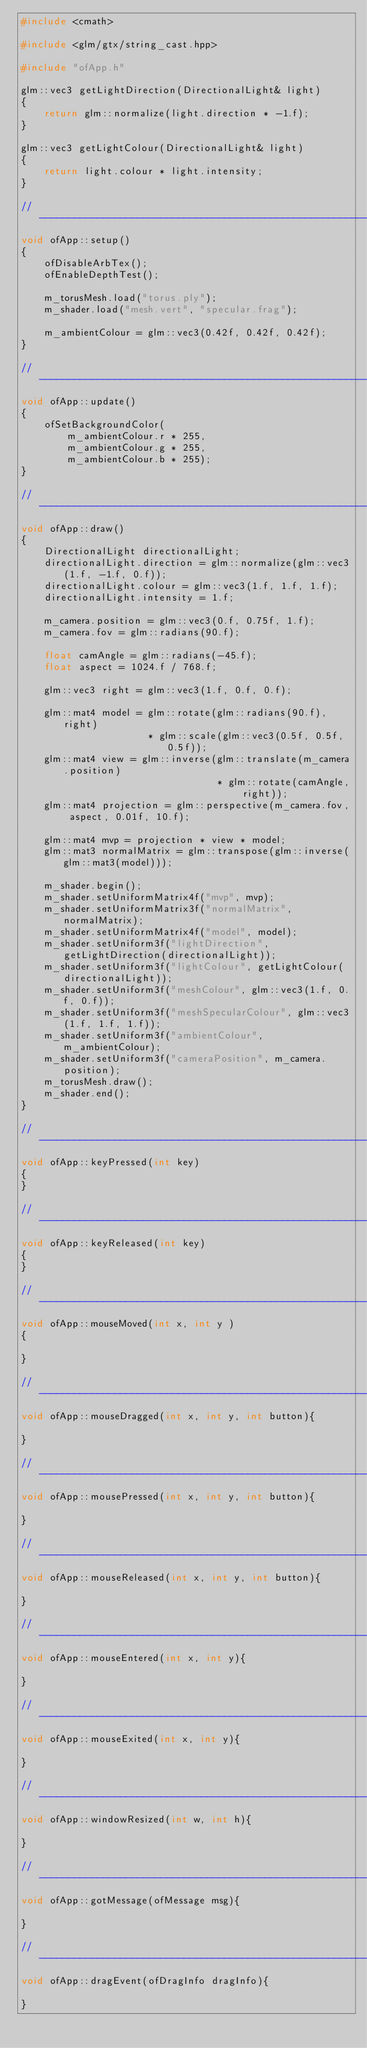Convert code to text. <code><loc_0><loc_0><loc_500><loc_500><_C++_>#include <cmath>

#include <glm/gtx/string_cast.hpp>

#include "ofApp.h"

glm::vec3 getLightDirection(DirectionalLight& light)
{
    return glm::normalize(light.direction * -1.f);
}

glm::vec3 getLightColour(DirectionalLight& light)
{
    return light.colour * light.intensity;
}

//--------------------------------------------------------------
void ofApp::setup()
{
    ofDisableArbTex();
    ofEnableDepthTest();

    m_torusMesh.load("torus.ply");
    m_shader.load("mesh.vert", "specular.frag");

    m_ambientColour = glm::vec3(0.42f, 0.42f, 0.42f);
}

//--------------------------------------------------------------
void ofApp::update()
{
    ofSetBackgroundColor(
        m_ambientColour.r * 255,
        m_ambientColour.g * 255,
        m_ambientColour.b * 255);
}

//--------------------------------------------------------------
void ofApp::draw()
{
    DirectionalLight directionalLight;
    directionalLight.direction = glm::normalize(glm::vec3(1.f, -1.f, 0.f));
    directionalLight.colour = glm::vec3(1.f, 1.f, 1.f);
    directionalLight.intensity = 1.f;

    m_camera.position = glm::vec3(0.f, 0.75f, 1.f);
    m_camera.fov = glm::radians(90.f);

    float camAngle = glm::radians(-45.f);
    float aspect = 1024.f / 768.f;

    glm::vec3 right = glm::vec3(1.f, 0.f, 0.f);

    glm::mat4 model = glm::rotate(glm::radians(90.f), right)
                      * glm::scale(glm::vec3(0.5f, 0.5f, 0.5f));
    glm::mat4 view = glm::inverse(glm::translate(m_camera.position)
                                  * glm::rotate(camAngle, right));
    glm::mat4 projection = glm::perspective(m_camera.fov, aspect, 0.01f, 10.f);

    glm::mat4 mvp = projection * view * model;
    glm::mat3 normalMatrix = glm::transpose(glm::inverse(glm::mat3(model)));

    m_shader.begin();
    m_shader.setUniformMatrix4f("mvp", mvp);
    m_shader.setUniformMatrix3f("normalMatrix", normalMatrix);
    m_shader.setUniformMatrix4f("model", model);
    m_shader.setUniform3f("lightDirection", getLightDirection(directionalLight));
    m_shader.setUniform3f("lightColour", getLightColour(directionalLight));
    m_shader.setUniform3f("meshColour", glm::vec3(1.f, 0.f, 0.f));
    m_shader.setUniform3f("meshSpecularColour", glm::vec3(1.f, 1.f, 1.f));
    m_shader.setUniform3f("ambientColour", m_ambientColour);
    m_shader.setUniform3f("cameraPosition", m_camera.position);
    m_torusMesh.draw();
    m_shader.end();
}

//--------------------------------------------------------------
void ofApp::keyPressed(int key)
{
}

//--------------------------------------------------------------
void ofApp::keyReleased(int key)
{
}

//--------------------------------------------------------------
void ofApp::mouseMoved(int x, int y )
{

}

//--------------------------------------------------------------
void ofApp::mouseDragged(int x, int y, int button){

}

//--------------------------------------------------------------
void ofApp::mousePressed(int x, int y, int button){

}

//--------------------------------------------------------------
void ofApp::mouseReleased(int x, int y, int button){

}

//--------------------------------------------------------------
void ofApp::mouseEntered(int x, int y){

}

//--------------------------------------------------------------
void ofApp::mouseExited(int x, int y){

}

//--------------------------------------------------------------
void ofApp::windowResized(int w, int h){

}

//--------------------------------------------------------------
void ofApp::gotMessage(ofMessage msg){

}

//--------------------------------------------------------------
void ofApp::dragEvent(ofDragInfo dragInfo){

}
</code> 